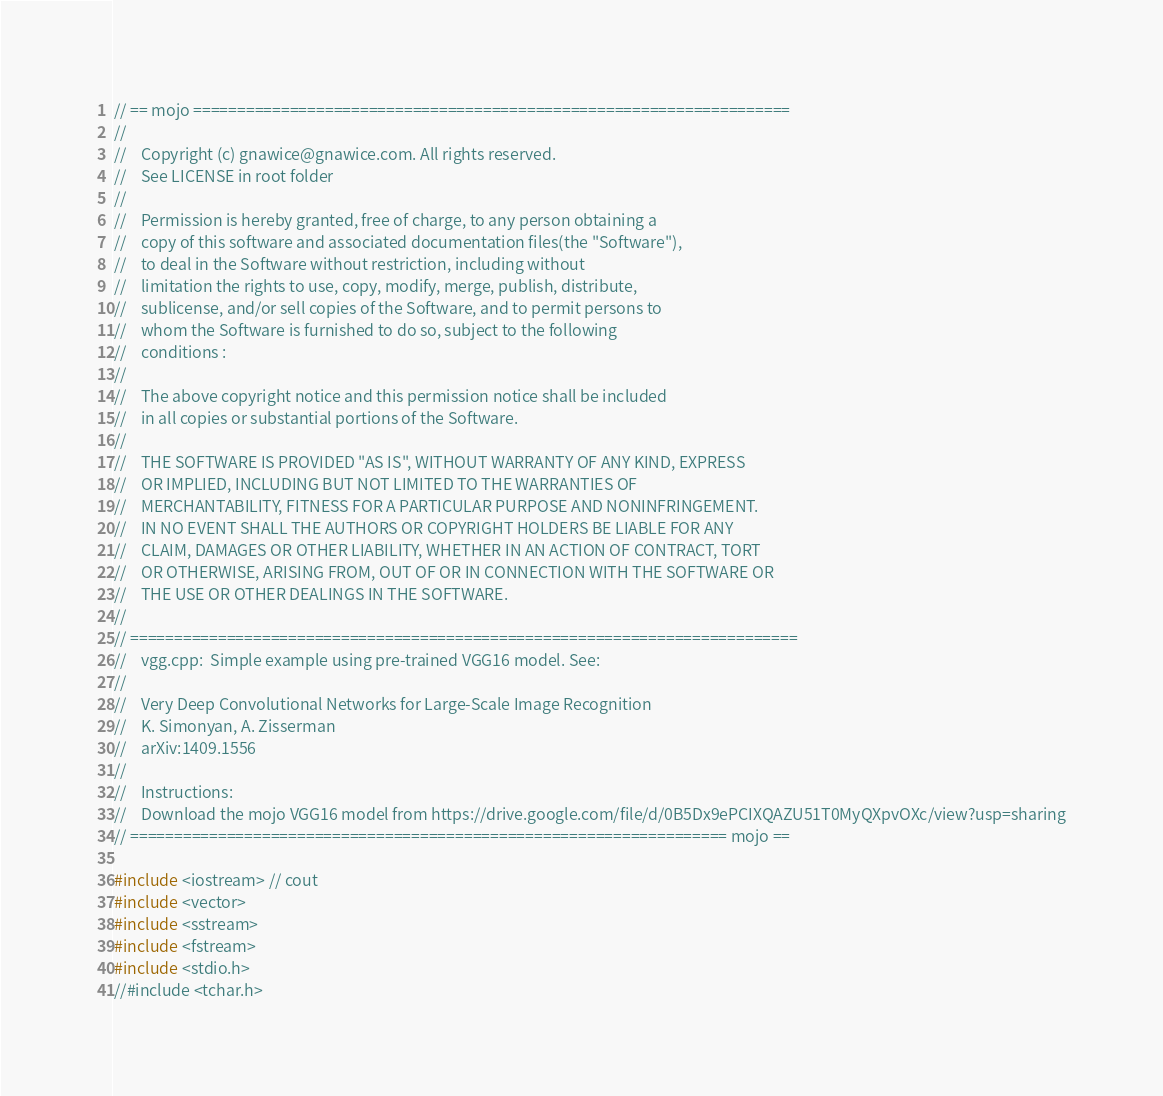<code> <loc_0><loc_0><loc_500><loc_500><_C++_>// == mojo ====================================================================
//
//    Copyright (c) gnawice@gnawice.com. All rights reserved.
//	  See LICENSE in root folder
//
//    Permission is hereby granted, free of charge, to any person obtaining a
//    copy of this software and associated documentation files(the "Software"),
//    to deal in the Software without restriction, including without 
//    limitation the rights to use, copy, modify, merge, publish, distribute,
//    sublicense, and/or sell copies of the Software, and to permit persons to
//    whom the Software is furnished to do so, subject to the following 
//    conditions :
//
//    The above copyright notice and this permission notice shall be included
//    in all copies or substantial portions of the Software.
//
//    THE SOFTWARE IS PROVIDED "AS IS", WITHOUT WARRANTY OF ANY KIND, EXPRESS
//    OR IMPLIED, INCLUDING BUT NOT LIMITED TO THE WARRANTIES OF 
//    MERCHANTABILITY, FITNESS FOR A PARTICULAR PURPOSE AND NONINFRINGEMENT.
//    IN NO EVENT SHALL THE AUTHORS OR COPYRIGHT HOLDERS BE LIABLE FOR ANY
//    CLAIM, DAMAGES OR OTHER LIABILITY, WHETHER IN AN ACTION OF CONTRACT, TORT
//    OR OTHERWISE, ARISING FROM, OUT OF OR IN CONNECTION WITH THE SOFTWARE OR
//    THE USE OR OTHER DEALINGS IN THE SOFTWARE.
//
// ============================================================================
//    vgg.cpp:  Simple example using pre-trained VGG16 model. See:
//
//    Very Deep Convolutional Networks for Large-Scale Image Recognition
//    K. Simonyan, A. Zisserman
//    arXiv:1409.1556
//
//    Instructions: 
//	  Download the mojo VGG16 model from https://drive.google.com/file/d/0B5Dx9ePCIXQAZU51T0MyQXpvOXc/view?usp=sharing
// ==================================================================== mojo ==

#include <iostream> // cout
#include <vector>
#include <sstream>
#include <fstream>
#include <stdio.h>
//#include <tchar.h>
</code> 